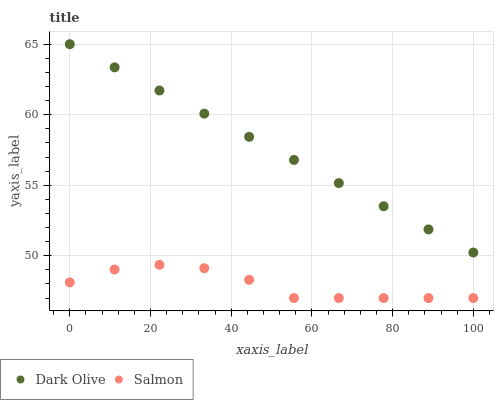Does Salmon have the minimum area under the curve?
Answer yes or no. Yes. Does Dark Olive have the maximum area under the curve?
Answer yes or no. Yes. Does Salmon have the maximum area under the curve?
Answer yes or no. No. Is Dark Olive the smoothest?
Answer yes or no. Yes. Is Salmon the roughest?
Answer yes or no. Yes. Is Salmon the smoothest?
Answer yes or no. No. Does Salmon have the lowest value?
Answer yes or no. Yes. Does Dark Olive have the highest value?
Answer yes or no. Yes. Does Salmon have the highest value?
Answer yes or no. No. Is Salmon less than Dark Olive?
Answer yes or no. Yes. Is Dark Olive greater than Salmon?
Answer yes or no. Yes. Does Salmon intersect Dark Olive?
Answer yes or no. No. 